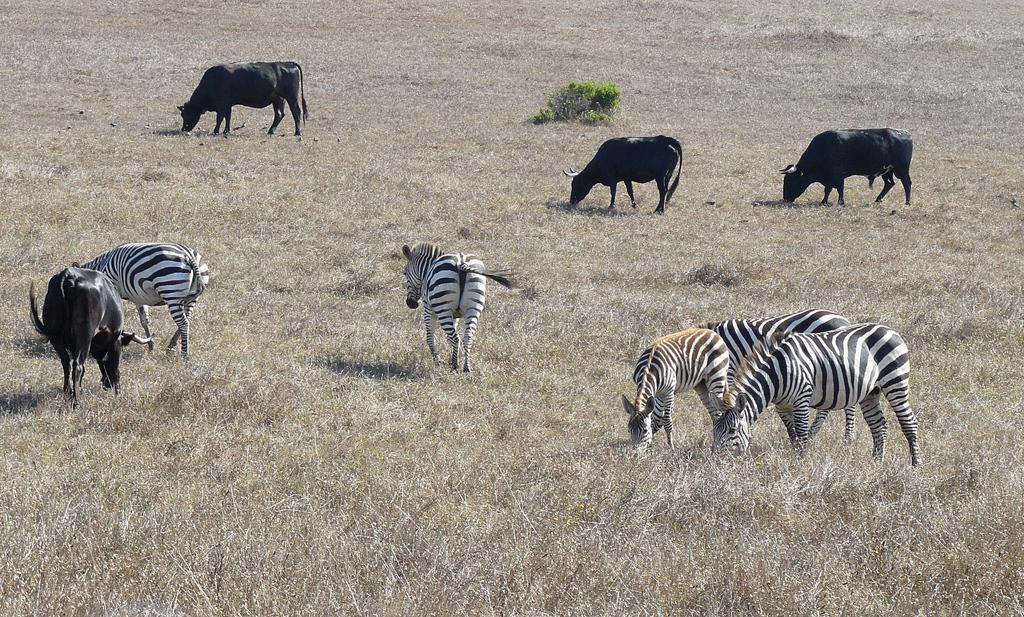What animals can be seen in the image? There are zebras and cattle in the image. What are the zebras and cattle doing in the image? The zebras and cattle are standing on the ground and grazing. What type of vegetation is present in the image? There are plants and grass in the image. Where is the nearest airport to the location depicted in the image? The provided facts do not mention any information about an airport, so it cannot be determined from the image. What type of waste can be seen in the image? There is no waste visible in the image; it features zebras, cattle, plants, and grass. 